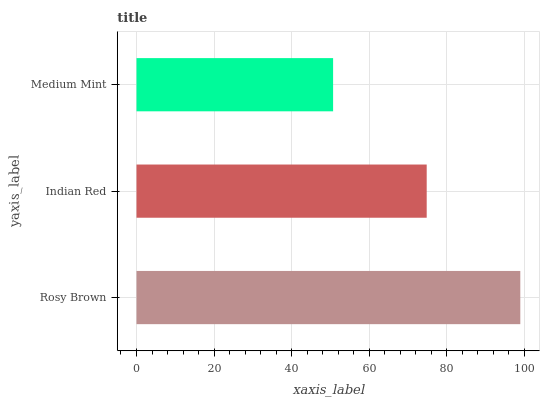Is Medium Mint the minimum?
Answer yes or no. Yes. Is Rosy Brown the maximum?
Answer yes or no. Yes. Is Indian Red the minimum?
Answer yes or no. No. Is Indian Red the maximum?
Answer yes or no. No. Is Rosy Brown greater than Indian Red?
Answer yes or no. Yes. Is Indian Red less than Rosy Brown?
Answer yes or no. Yes. Is Indian Red greater than Rosy Brown?
Answer yes or no. No. Is Rosy Brown less than Indian Red?
Answer yes or no. No. Is Indian Red the high median?
Answer yes or no. Yes. Is Indian Red the low median?
Answer yes or no. Yes. Is Rosy Brown the high median?
Answer yes or no. No. Is Rosy Brown the low median?
Answer yes or no. No. 